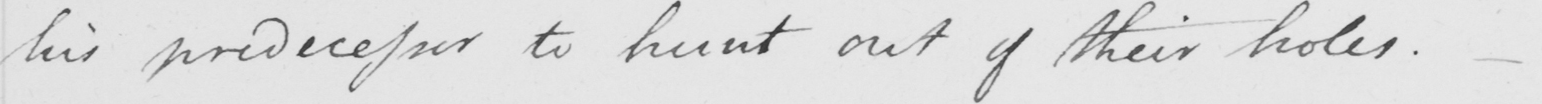Can you tell me what this handwritten text says? his predecessor to hunt out of their holes .  _ 